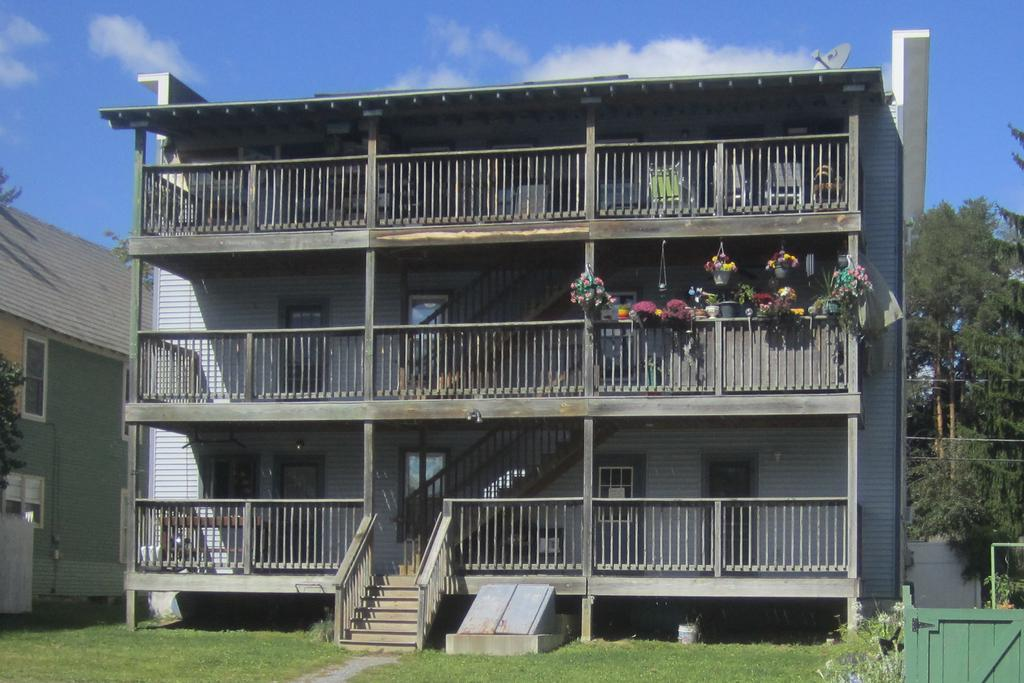What type of structure is present in the image? There is a building in the image. What is located near the building? There is a fence in the image. What type of vegetation can be seen in the image? There are house plants in the image. Are there any architectural features in the image? Yes, there are steps in the image. What can be seen through the windows in the image? The windows in the image provide a view of the surrounding area. What type of residence is depicted in the image? There is a house in the image. What is the ground surface like in the image? There is grass visible in the image. What is visible in the background of the image? Trees and the sky are visible in the background of the image. What is the condition of the sky in the image? There are clouds in the sky in the image. How many planes are flying over the house in the image? There are no planes visible in the image. What stage of development is the house in the image? The image does not provide information about the development stage of the house. 